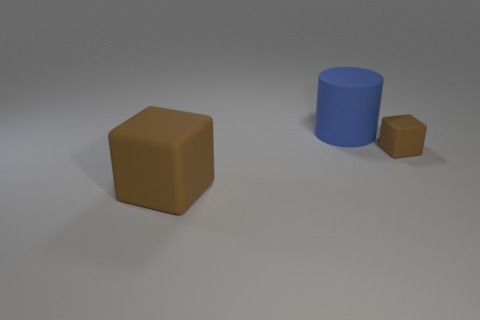Add 1 big blocks. How many objects exist? 4 Subtract all cylinders. How many objects are left? 2 Add 3 blue objects. How many blue objects are left? 4 Add 1 large matte cylinders. How many large matte cylinders exist? 2 Subtract 0 green spheres. How many objects are left? 3 Subtract all blue matte cylinders. Subtract all large matte cylinders. How many objects are left? 1 